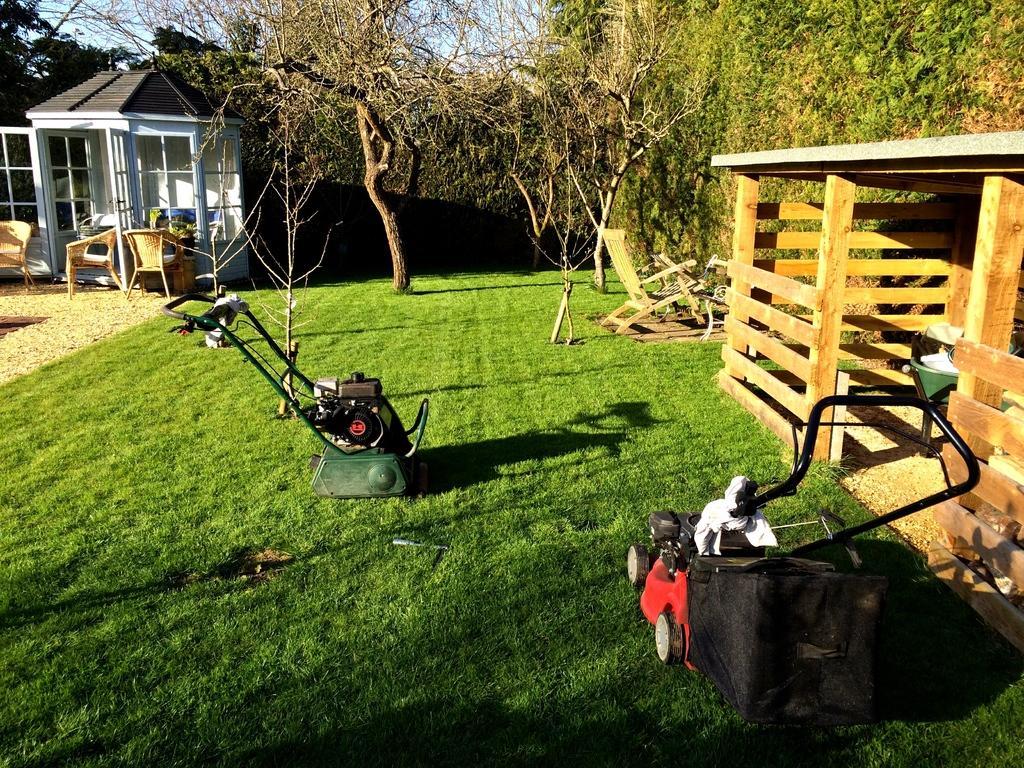In one or two sentences, can you explain what this image depicts? In this image there is a ground on which there are two cutters. On the right side there is a wooden house. On the left side there are chairs on the ground. In the background there are trees. On the left side top there is a small house with the glass doors. On the ground there is grass. On the right side there is a wooden chair. 